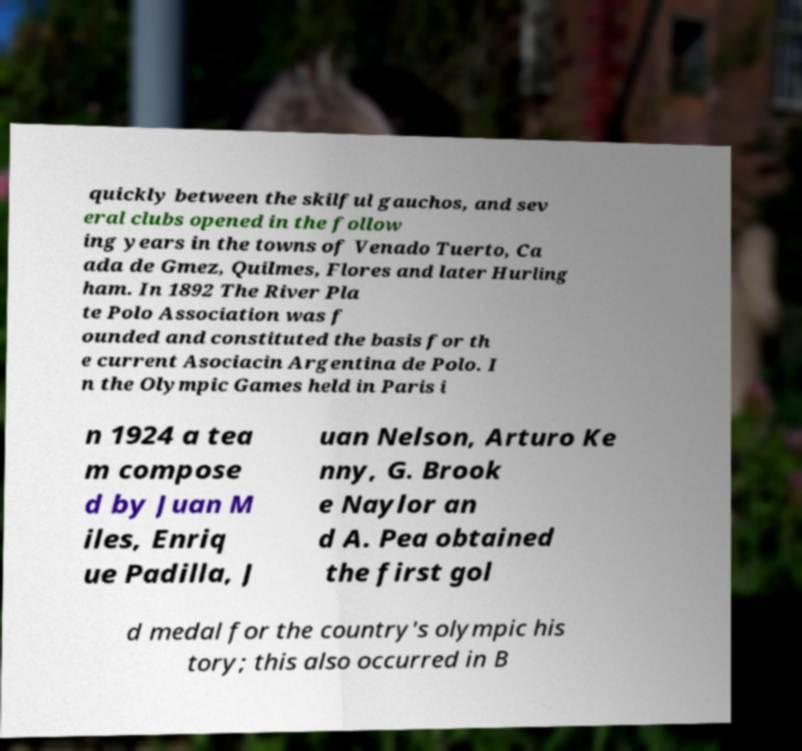Please read and relay the text visible in this image. What does it say? quickly between the skilful gauchos, and sev eral clubs opened in the follow ing years in the towns of Venado Tuerto, Ca ada de Gmez, Quilmes, Flores and later Hurling ham. In 1892 The River Pla te Polo Association was f ounded and constituted the basis for th e current Asociacin Argentina de Polo. I n the Olympic Games held in Paris i n 1924 a tea m compose d by Juan M iles, Enriq ue Padilla, J uan Nelson, Arturo Ke nny, G. Brook e Naylor an d A. Pea obtained the first gol d medal for the country's olympic his tory; this also occurred in B 